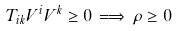Convert formula to latex. <formula><loc_0><loc_0><loc_500><loc_500>T _ { i k } V ^ { i } V ^ { k } \geq 0 \, \Longrightarrow \, \rho \geq 0</formula> 